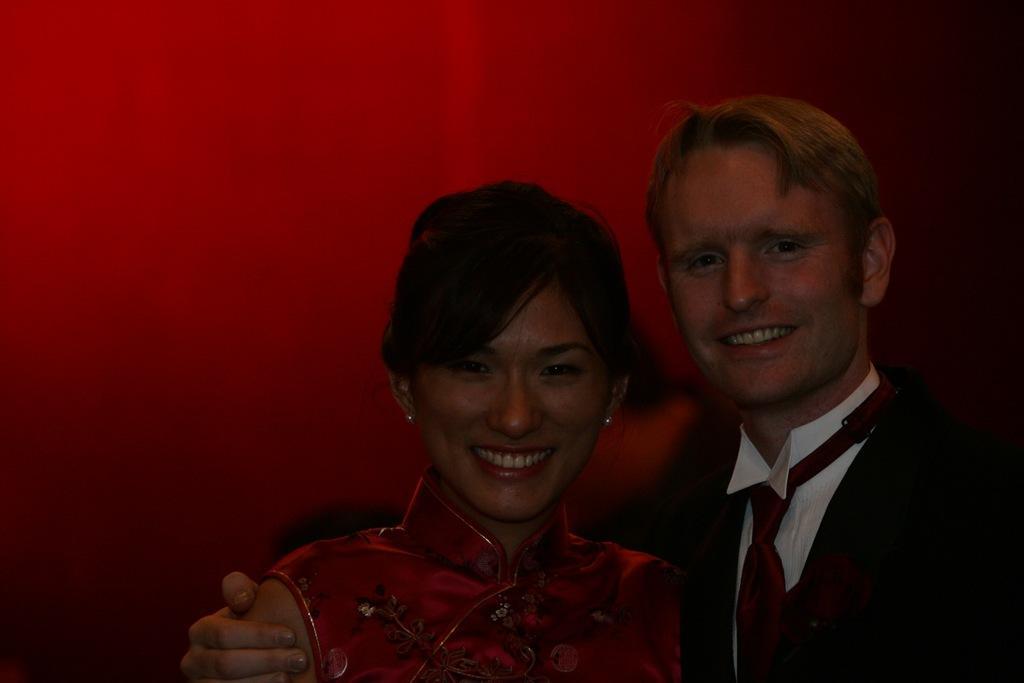Please provide a concise description of this image. In the foreground of this picture, there is a couple standing and posing to the camera. In the background, there is a red color wall. 